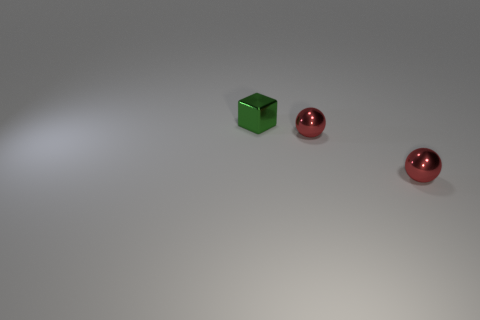Are there any other cubes of the same size as the shiny cube?
Offer a very short reply. No. Is the number of things that are left of the tiny cube less than the number of green shiny cubes?
Keep it short and to the point. Yes. The green object is what size?
Provide a short and direct response. Small. How many large objects are gray matte things or spheres?
Make the answer very short. 0. What number of metal objects are red things or blocks?
Your answer should be compact. 3. Is there anything else that has the same shape as the tiny green metal thing?
Offer a terse response. No. What number of objects are tiny metal things or metallic things right of the metallic block?
Your response must be concise. 3. Is there anything else that is the same size as the shiny block?
Offer a terse response. Yes. There is a small green shiny block; are there any red objects to the left of it?
Provide a succinct answer. No. Is there a tiny red metal thing that has the same shape as the green object?
Make the answer very short. No. 